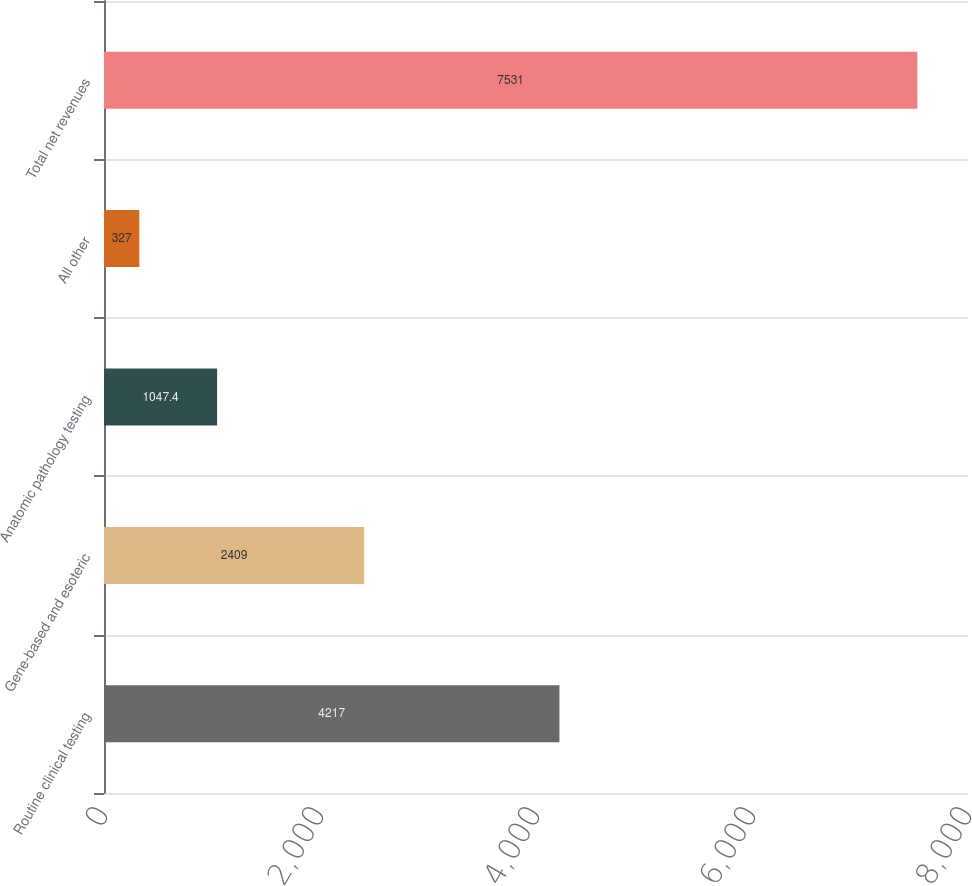Convert chart to OTSL. <chart><loc_0><loc_0><loc_500><loc_500><bar_chart><fcel>Routine clinical testing<fcel>Gene-based and esoteric<fcel>Anatomic pathology testing<fcel>All other<fcel>Total net revenues<nl><fcel>4217<fcel>2409<fcel>1047.4<fcel>327<fcel>7531<nl></chart> 